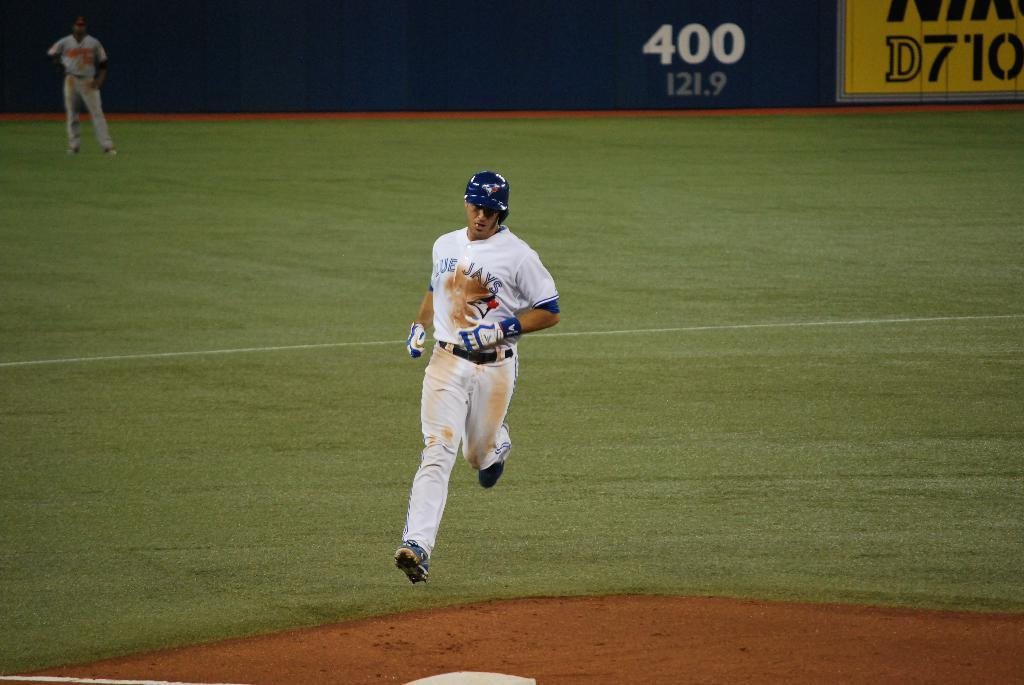What is the man in the image doing? The man is running in the image. What is the setting of the image? The image depicts a playground. What can be seen in the background of the image? There is a board and a person standing in the background of the image. What type of chin can be seen on the crayon in the image? There is no crayon present in the image, and therefore no chin can be seen on it. What is the person in the background of the image reading? There is no indication in the image that the person in the background is reading anything. 